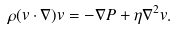Convert formula to latex. <formula><loc_0><loc_0><loc_500><loc_500>\rho ( { v } \cdot \nabla ) { v } = - \nabla P + \eta \nabla ^ { 2 } { v } .</formula> 